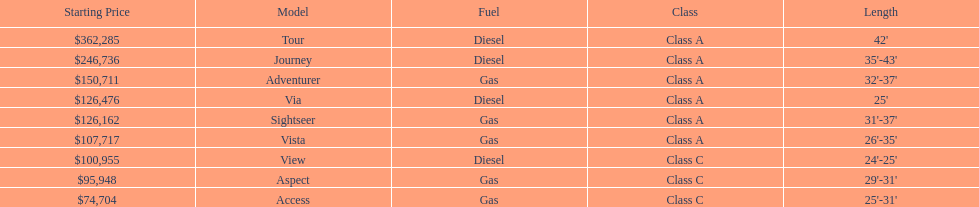How many models are available in lengths longer than 30 feet? 7. 